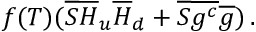<formula> <loc_0><loc_0><loc_500><loc_500>f ( T ) ( \overline { S } \overline { H } _ { u } \overline { H } _ { d } + \overline { S } \overline { { { g ^ { c } } } } \overline { g } ) \, .</formula> 